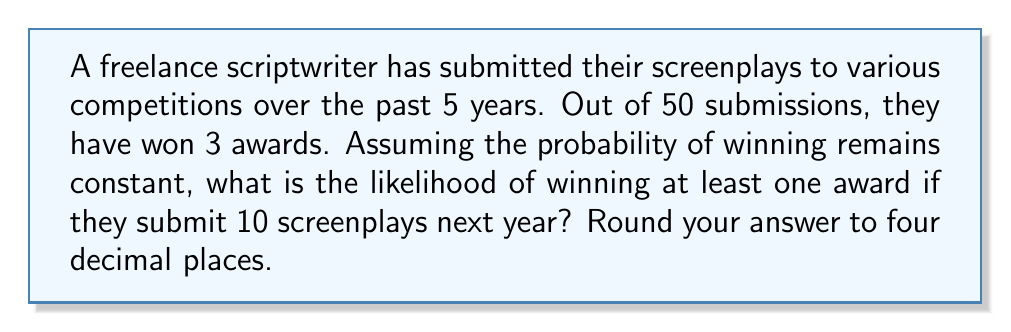Could you help me with this problem? Let's approach this step-by-step:

1) First, we need to calculate the probability of winning a single award based on past data:
   $p = \frac{\text{number of wins}}{\text{number of submissions}} = \frac{3}{50} = 0.06$

2) The probability of not winning an award for a single submission is:
   $q = 1 - p = 1 - 0.06 = 0.94$

3) We want to find the probability of winning at least one award in 10 submissions. This is equivalent to 1 minus the probability of winning no awards in 10 submissions.

4) The probability of winning no awards in 10 submissions is:
   $P(\text{no wins}) = q^{10} = 0.94^{10} = 0.5386$

5) Therefore, the probability of winning at least one award is:
   $P(\text{at least one win}) = 1 - P(\text{no wins}) = 1 - 0.5386 = 0.4614$

6) Rounding to four decimal places:
   $0.4614 \approx 0.4614$
Answer: 0.4614 